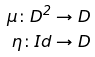<formula> <loc_0><loc_0><loc_500><loc_500>\mu \colon D ^ { 2 } \rightarrow D \\ \eta \colon I d \rightarrow D</formula> 